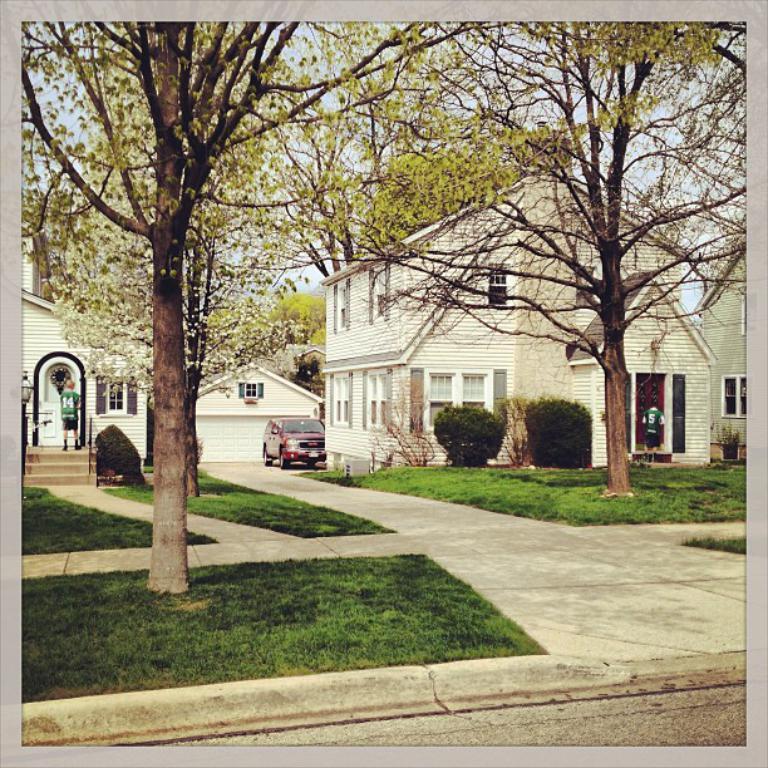How would you summarize this image in a sentence or two? In this image we can see buildings, persons standing, motor vehicle, bushes, trees and sky. 